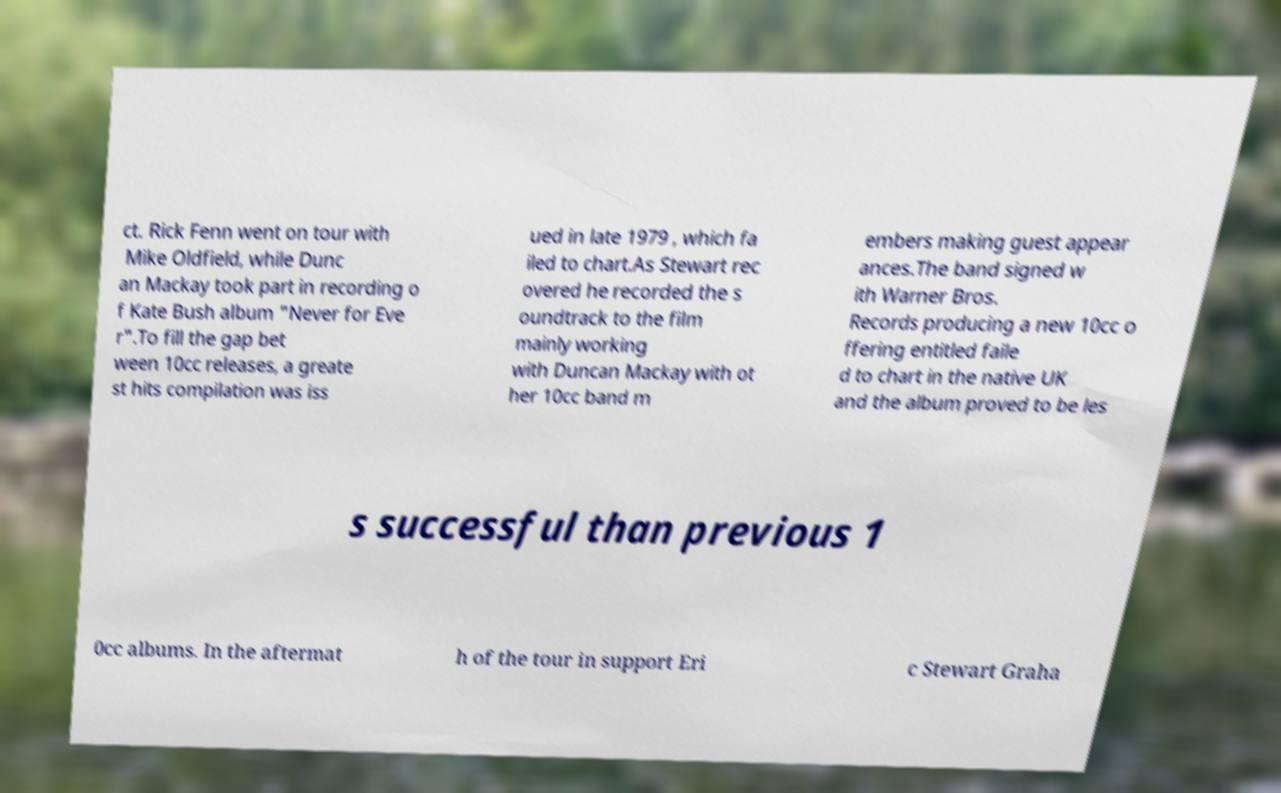There's text embedded in this image that I need extracted. Can you transcribe it verbatim? ct. Rick Fenn went on tour with Mike Oldfield, while Dunc an Mackay took part in recording o f Kate Bush album "Never for Eve r".To fill the gap bet ween 10cc releases, a greate st hits compilation was iss ued in late 1979 , which fa iled to chart.As Stewart rec overed he recorded the s oundtrack to the film mainly working with Duncan Mackay with ot her 10cc band m embers making guest appear ances.The band signed w ith Warner Bros. Records producing a new 10cc o ffering entitled faile d to chart in the native UK and the album proved to be les s successful than previous 1 0cc albums. In the aftermat h of the tour in support Eri c Stewart Graha 